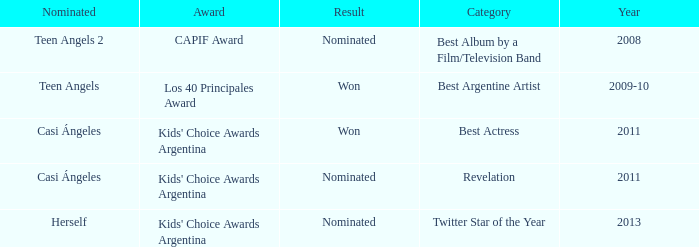What year was Teen Angels 2 nominated? 2008.0. 